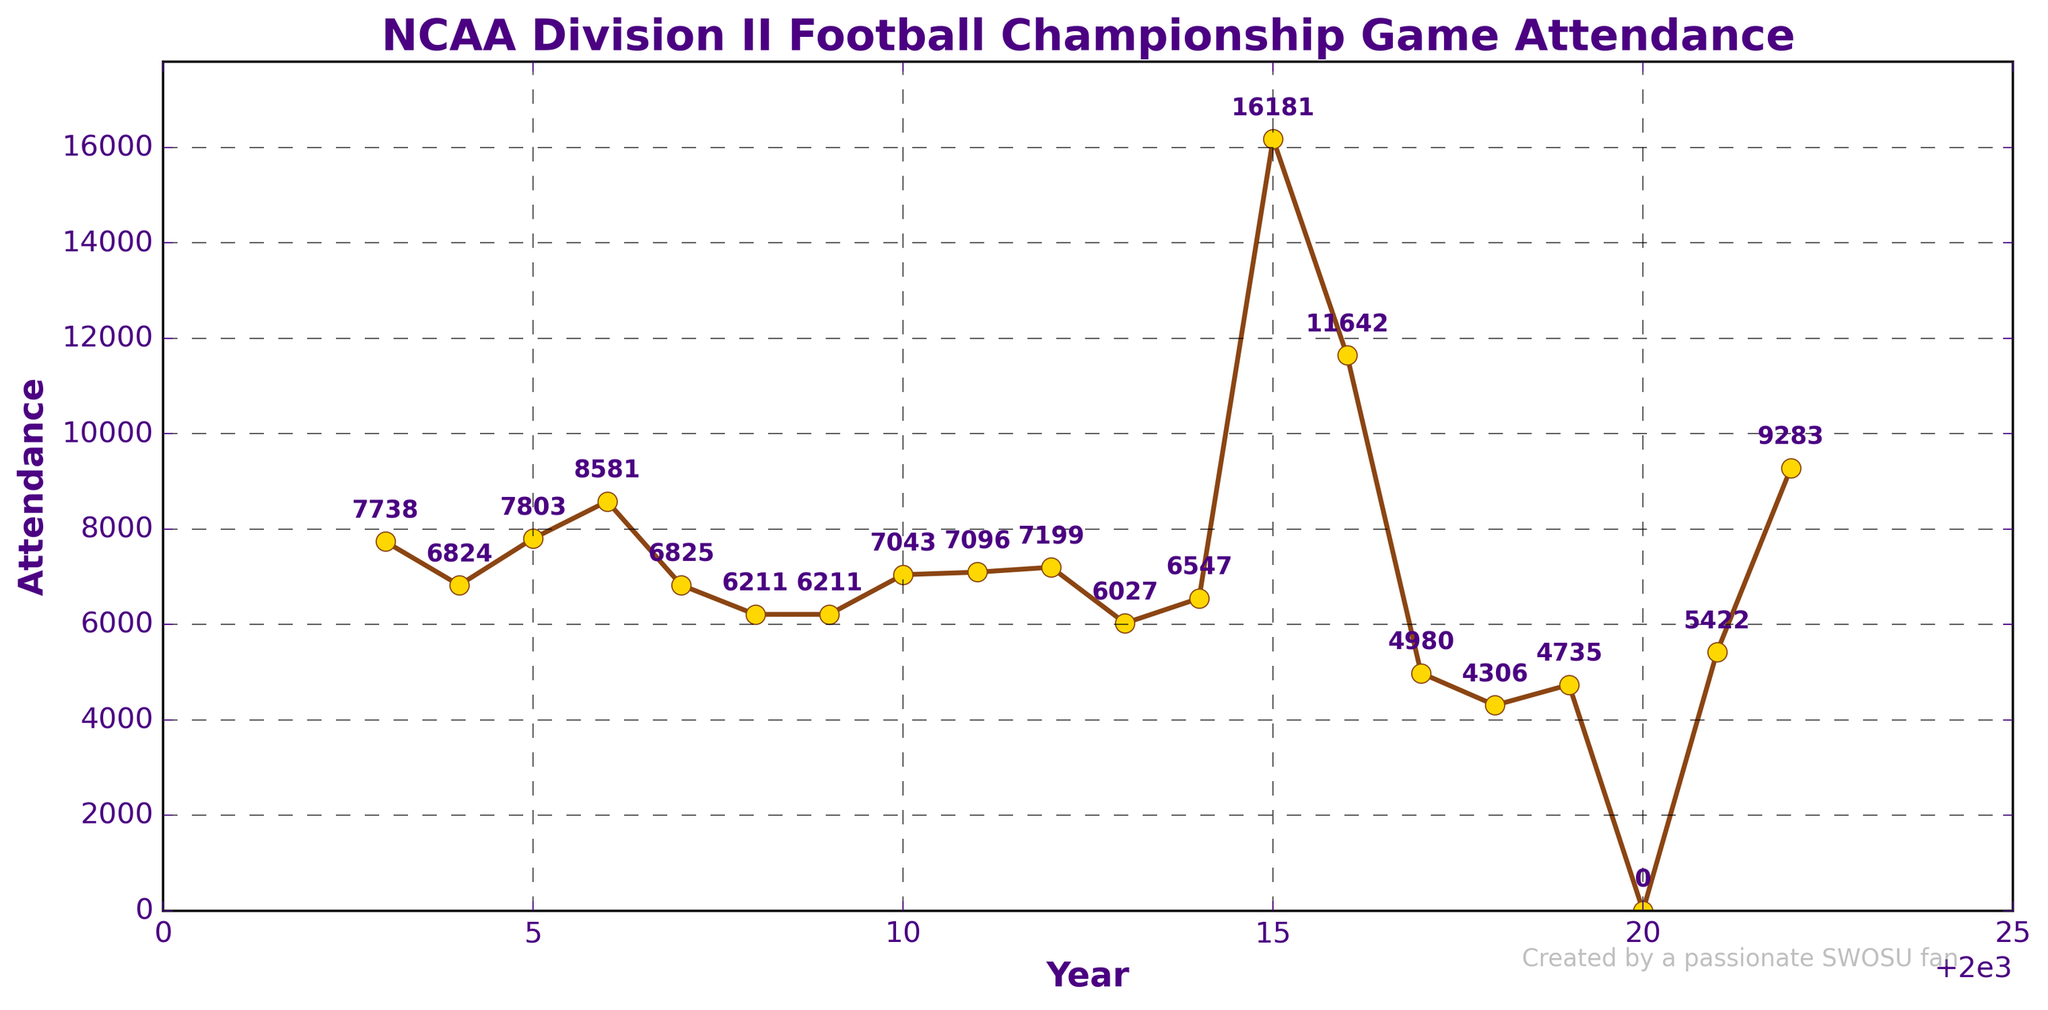Which year had the highest attendance for the NCAA Division II Football Championship game? Look at the chart and find the year where the attendance peaks at the highest point.
Answer: 2015 How many times did the attendance exceed 10,000? Identify the years where the y-axis value is over 10,000 and count them.
Answer: 2 What is the median attendance value over the 20-year period? Arrange the attendance values in ascending order and find the middle value. Since there are 20 data points, the median is the average of the 10th and 11th values.
Answer: 7043.5 Which year showed the biggest drop in attendance compared to the previous year? Calculate the difference in attendance between each consecutive year and identify the year with the largest negative difference.
Answer: 2017 Compare the average attendance before 2015 to the average attendance after 2015. Which period had a higher average? Calculate the average attendance for the years 2003-2014 and 2015-2022 separately, then compare the two averages.
Answer: After 2015 Which years saw a change in the location of the championship game? Look for years where there is a change in place as indicated by a consistent pattern in the plot and then an observable change.
Answer: 2014 and 2018 By approximately how much did attendance drop during the shift from Florence, AL to Kansas City, KS in 2014? Subtract the attendance in 2013 from the attendance in 2014 to find the difference.
Answer: 520 Which team appears most frequently as the winner during these years? Examine the winner column and count the number of times each team appears.
Answer: Northwest Missouri State Discuss the visual trend of attendance from 2003 to 2022, paying attention to any notable spikes or drops. Observe the line path in the chart from 2003 to 2022, noting years with significant changes and overall trends.
Answer: Trend shows some fluctuations with significant spikes in 2015 and 2016, drop in 2017, and another increase in 2022 What is the visual representation used to highlight the founding year of Southwestern Oklahoma State University, and what does it signify? Observe any special markers or lines in the figure, especially around the year 1901, and explain their significance.
Answer: Vertical dashed line labeled "SWOSU Founded" at 1901 